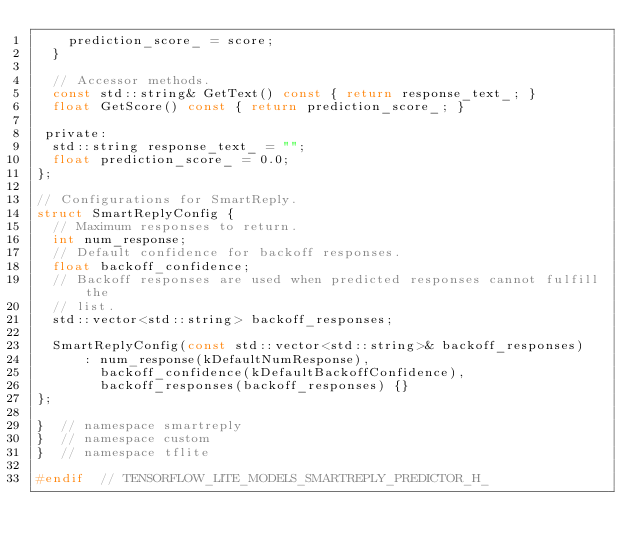<code> <loc_0><loc_0><loc_500><loc_500><_C_>    prediction_score_ = score;
  }

  // Accessor methods.
  const std::string& GetText() const { return response_text_; }
  float GetScore() const { return prediction_score_; }

 private:
  std::string response_text_ = "";
  float prediction_score_ = 0.0;
};

// Configurations for SmartReply.
struct SmartReplyConfig {
  // Maximum responses to return.
  int num_response;
  // Default confidence for backoff responses.
  float backoff_confidence;
  // Backoff responses are used when predicted responses cannot fulfill the
  // list.
  std::vector<std::string> backoff_responses;

  SmartReplyConfig(const std::vector<std::string>& backoff_responses)
      : num_response(kDefaultNumResponse),
        backoff_confidence(kDefaultBackoffConfidence),
        backoff_responses(backoff_responses) {}
};

}  // namespace smartreply
}  // namespace custom
}  // namespace tflite

#endif  // TENSORFLOW_LITE_MODELS_SMARTREPLY_PREDICTOR_H_
</code> 